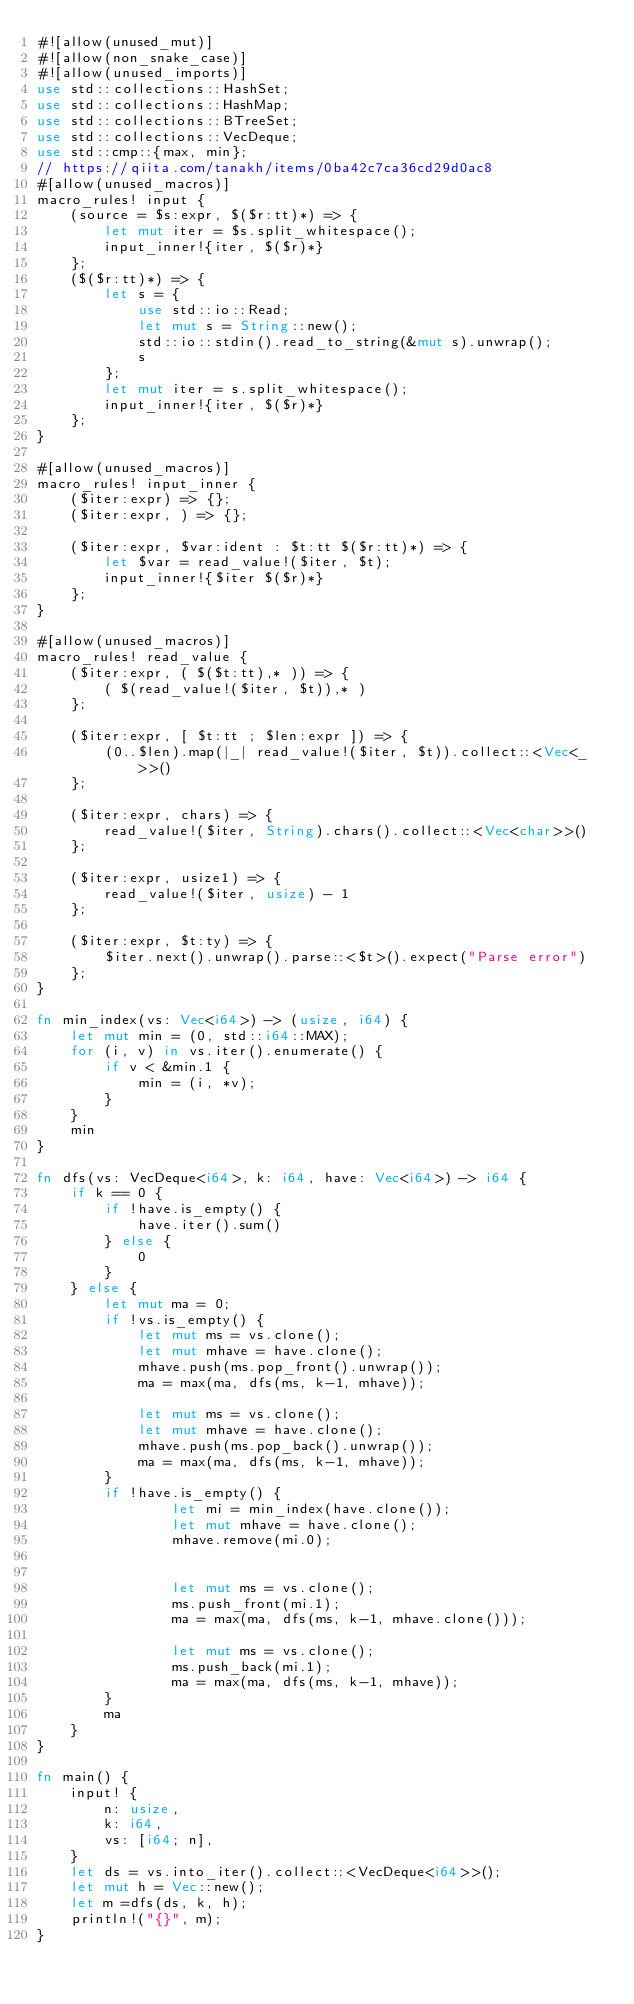<code> <loc_0><loc_0><loc_500><loc_500><_Rust_>#![allow(unused_mut)]
#![allow(non_snake_case)]
#![allow(unused_imports)]
use std::collections::HashSet;
use std::collections::HashMap;
use std::collections::BTreeSet;
use std::collections::VecDeque;
use std::cmp::{max, min};
// https://qiita.com/tanakh/items/0ba42c7ca36cd29d0ac8
#[allow(unused_macros)]
macro_rules! input {
    (source = $s:expr, $($r:tt)*) => {
        let mut iter = $s.split_whitespace();
        input_inner!{iter, $($r)*}
    };
    ($($r:tt)*) => {
        let s = {
            use std::io::Read;
            let mut s = String::new();
            std::io::stdin().read_to_string(&mut s).unwrap();
            s
        };
        let mut iter = s.split_whitespace();
        input_inner!{iter, $($r)*}
    };
}

#[allow(unused_macros)]
macro_rules! input_inner {
    ($iter:expr) => {};
    ($iter:expr, ) => {};

    ($iter:expr, $var:ident : $t:tt $($r:tt)*) => {
        let $var = read_value!($iter, $t);
        input_inner!{$iter $($r)*}
    };
}

#[allow(unused_macros)]
macro_rules! read_value {
    ($iter:expr, ( $($t:tt),* )) => {
        ( $(read_value!($iter, $t)),* )
    };

    ($iter:expr, [ $t:tt ; $len:expr ]) => {
        (0..$len).map(|_| read_value!($iter, $t)).collect::<Vec<_>>()
    };

    ($iter:expr, chars) => {
        read_value!($iter, String).chars().collect::<Vec<char>>()
    };

    ($iter:expr, usize1) => {
        read_value!($iter, usize) - 1
    };

    ($iter:expr, $t:ty) => {
        $iter.next().unwrap().parse::<$t>().expect("Parse error")
    };
}

fn min_index(vs: Vec<i64>) -> (usize, i64) {
    let mut min = (0, std::i64::MAX);
    for (i, v) in vs.iter().enumerate() {
        if v < &min.1 {
            min = (i, *v);
        }
    }
    min
}

fn dfs(vs: VecDeque<i64>, k: i64, have: Vec<i64>) -> i64 {
    if k == 0 {
        if !have.is_empty() {
            have.iter().sum()
        } else {
            0
        }
    } else {
        let mut ma = 0;
        if !vs.is_empty() {
            let mut ms = vs.clone();
            let mut mhave = have.clone();
            mhave.push(ms.pop_front().unwrap());
            ma = max(ma, dfs(ms, k-1, mhave));

            let mut ms = vs.clone();
            let mut mhave = have.clone();
            mhave.push(ms.pop_back().unwrap());
            ma = max(ma, dfs(ms, k-1, mhave));
        }
        if !have.is_empty() {
                let mi = min_index(have.clone());
                let mut mhave = have.clone();
                mhave.remove(mi.0);


                let mut ms = vs.clone();
                ms.push_front(mi.1);
                ma = max(ma, dfs(ms, k-1, mhave.clone()));

                let mut ms = vs.clone();
                ms.push_back(mi.1);
                ma = max(ma, dfs(ms, k-1, mhave));
        }
        ma
    }
}

fn main() {
    input! {
        n: usize,
        k: i64,
        vs: [i64; n],
    }
    let ds = vs.into_iter().collect::<VecDeque<i64>>();
    let mut h = Vec::new();
    let m =dfs(ds, k, h);
    println!("{}", m);
}</code> 